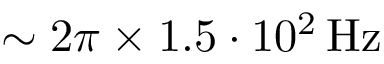Convert formula to latex. <formula><loc_0><loc_0><loc_500><loc_500>\sim 2 \pi \times 1 . 5 \cdot 1 0 ^ { 2 } \, H z</formula> 